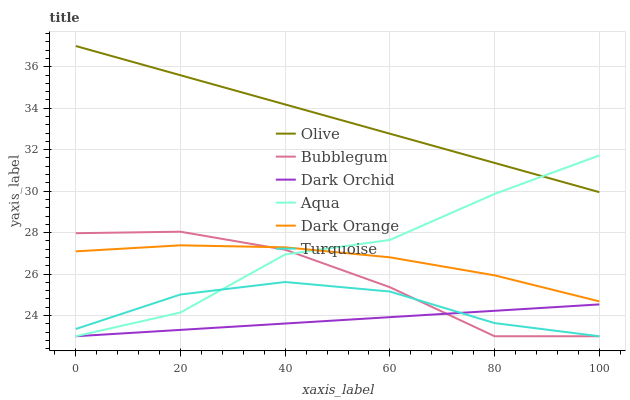Does Dark Orchid have the minimum area under the curve?
Answer yes or no. Yes. Does Olive have the maximum area under the curve?
Answer yes or no. Yes. Does Turquoise have the minimum area under the curve?
Answer yes or no. No. Does Turquoise have the maximum area under the curve?
Answer yes or no. No. Is Dark Orchid the smoothest?
Answer yes or no. Yes. Is Aqua the roughest?
Answer yes or no. Yes. Is Turquoise the smoothest?
Answer yes or no. No. Is Turquoise the roughest?
Answer yes or no. No. Does Turquoise have the lowest value?
Answer yes or no. Yes. Does Aqua have the lowest value?
Answer yes or no. No. Does Olive have the highest value?
Answer yes or no. Yes. Does Turquoise have the highest value?
Answer yes or no. No. Is Turquoise less than Dark Orange?
Answer yes or no. Yes. Is Dark Orange greater than Dark Orchid?
Answer yes or no. Yes. Does Aqua intersect Bubblegum?
Answer yes or no. Yes. Is Aqua less than Bubblegum?
Answer yes or no. No. Is Aqua greater than Bubblegum?
Answer yes or no. No. Does Turquoise intersect Dark Orange?
Answer yes or no. No. 